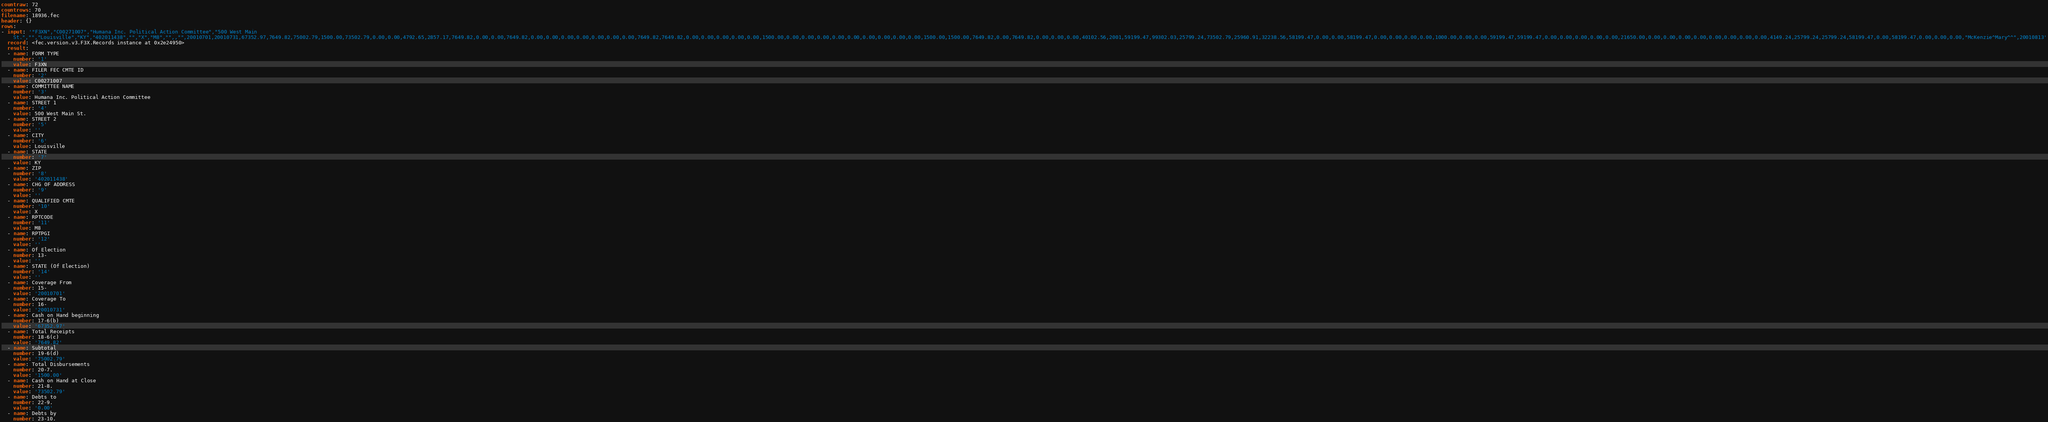Convert code to text. <code><loc_0><loc_0><loc_500><loc_500><_YAML_>countraw: 72
countrows: 70
filename: 18936.fec
header: {}
rows:
- input: '"F3XN","C00271007","Humana Inc. Political Action Committee","500 West Main
    St.","","Louisville","KY","402011438","","X","M8","",,"",20010701,20010731,67352.97,7649.82,75002.79,1500.00,73502.79,0.00,0.00,4792.65,2857.17,7649.82,0.00,0.00,7649.82,0.00,0.00,0.00,0.00,0.00,0.00,0.00,7649.82,7649.82,0.00,0.00,0.00,0.00,0.00,1500.00,0.00,0.00,0.00,0.00,0.00,0.00,0.00,0.00,0.00,1500.00,1500.00,7649.82,0.00,7649.82,0.00,0.00,0.00,40102.56,2001,59199.47,99302.03,25799.24,73502.79,25960.91,32238.56,58199.47,0.00,0.00,58199.47,0.00,0.00,0.00,0.00,1000.00,0.00,0.00,59199.47,59199.47,0.00,0.00,0.00,0.00,0.00,21650.00,0.00,0.00,0.00,0.00,0.00,0.00,0.00,0.00,4149.24,25799.24,25799.24,58199.47,0.00,58199.47,0.00,0.00,0.00,"McKenzie^Mary^^",20010813'
  record: <fec.version.v3.F3X.Records instance at 0x2e24950>
  result:
  - name: FORM TYPE
    number: '1'
    value: F3XN
  - name: FILER FEC CMTE ID
    number: '2'
    value: C00271007
  - name: COMMITTEE NAME
    number: '3'
    value: Humana Inc. Political Action Committee
  - name: STREET 1
    number: '4'
    value: 500 West Main St.
  - name: STREET 2
    number: '5'
    value: ''
  - name: CITY
    number: '6'
    value: Louisville
  - name: STATE
    number: '7'
    value: KY
  - name: ZIP
    number: '8'
    value: '402011438'
  - name: CHG OF ADDRESS
    number: '9'
    value: ''
  - name: QUALIFIED CMTE
    number: '10'
    value: X
  - name: RPTCODE
    number: '11'
    value: M8
  - name: RPTPGI
    number: '12'
    value: ''
  - name: Of Election
    number: 13-
    value: ''
  - name: STATE (Of Election)
    number: '14'
    value: ''
  - name: Coverage From
    number: 15-
    value: '20010701'
  - name: Coverage To
    number: 16-
    value: '20010731'
  - name: Cash on Hand beginning
    number: 17-6(b)
    value: '67352.97'
  - name: Total Receipts
    number: 18-6(c)
    value: '7649.82'
  - name: Subtotal
    number: 19-6(d)
    value: '75002.79'
  - name: Total Disbursements
    number: 20-7.
    value: '1500.00'
  - name: Cash on Hand at Close
    number: 21-8.
    value: '73502.79'
  - name: Debts to
    number: 22-9.
    value: '0.00'
  - name: Debts by
    number: 23-10.</code> 